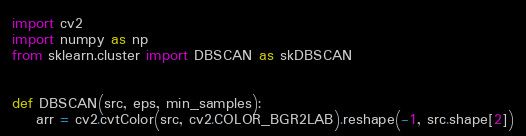<code> <loc_0><loc_0><loc_500><loc_500><_Python_>import cv2
import numpy as np
from sklearn.cluster import DBSCAN as skDBSCAN


def DBSCAN(src, eps, min_samples):
    arr = cv2.cvtColor(src, cv2.COLOR_BGR2LAB).reshape(-1, src.shape[2])</code> 